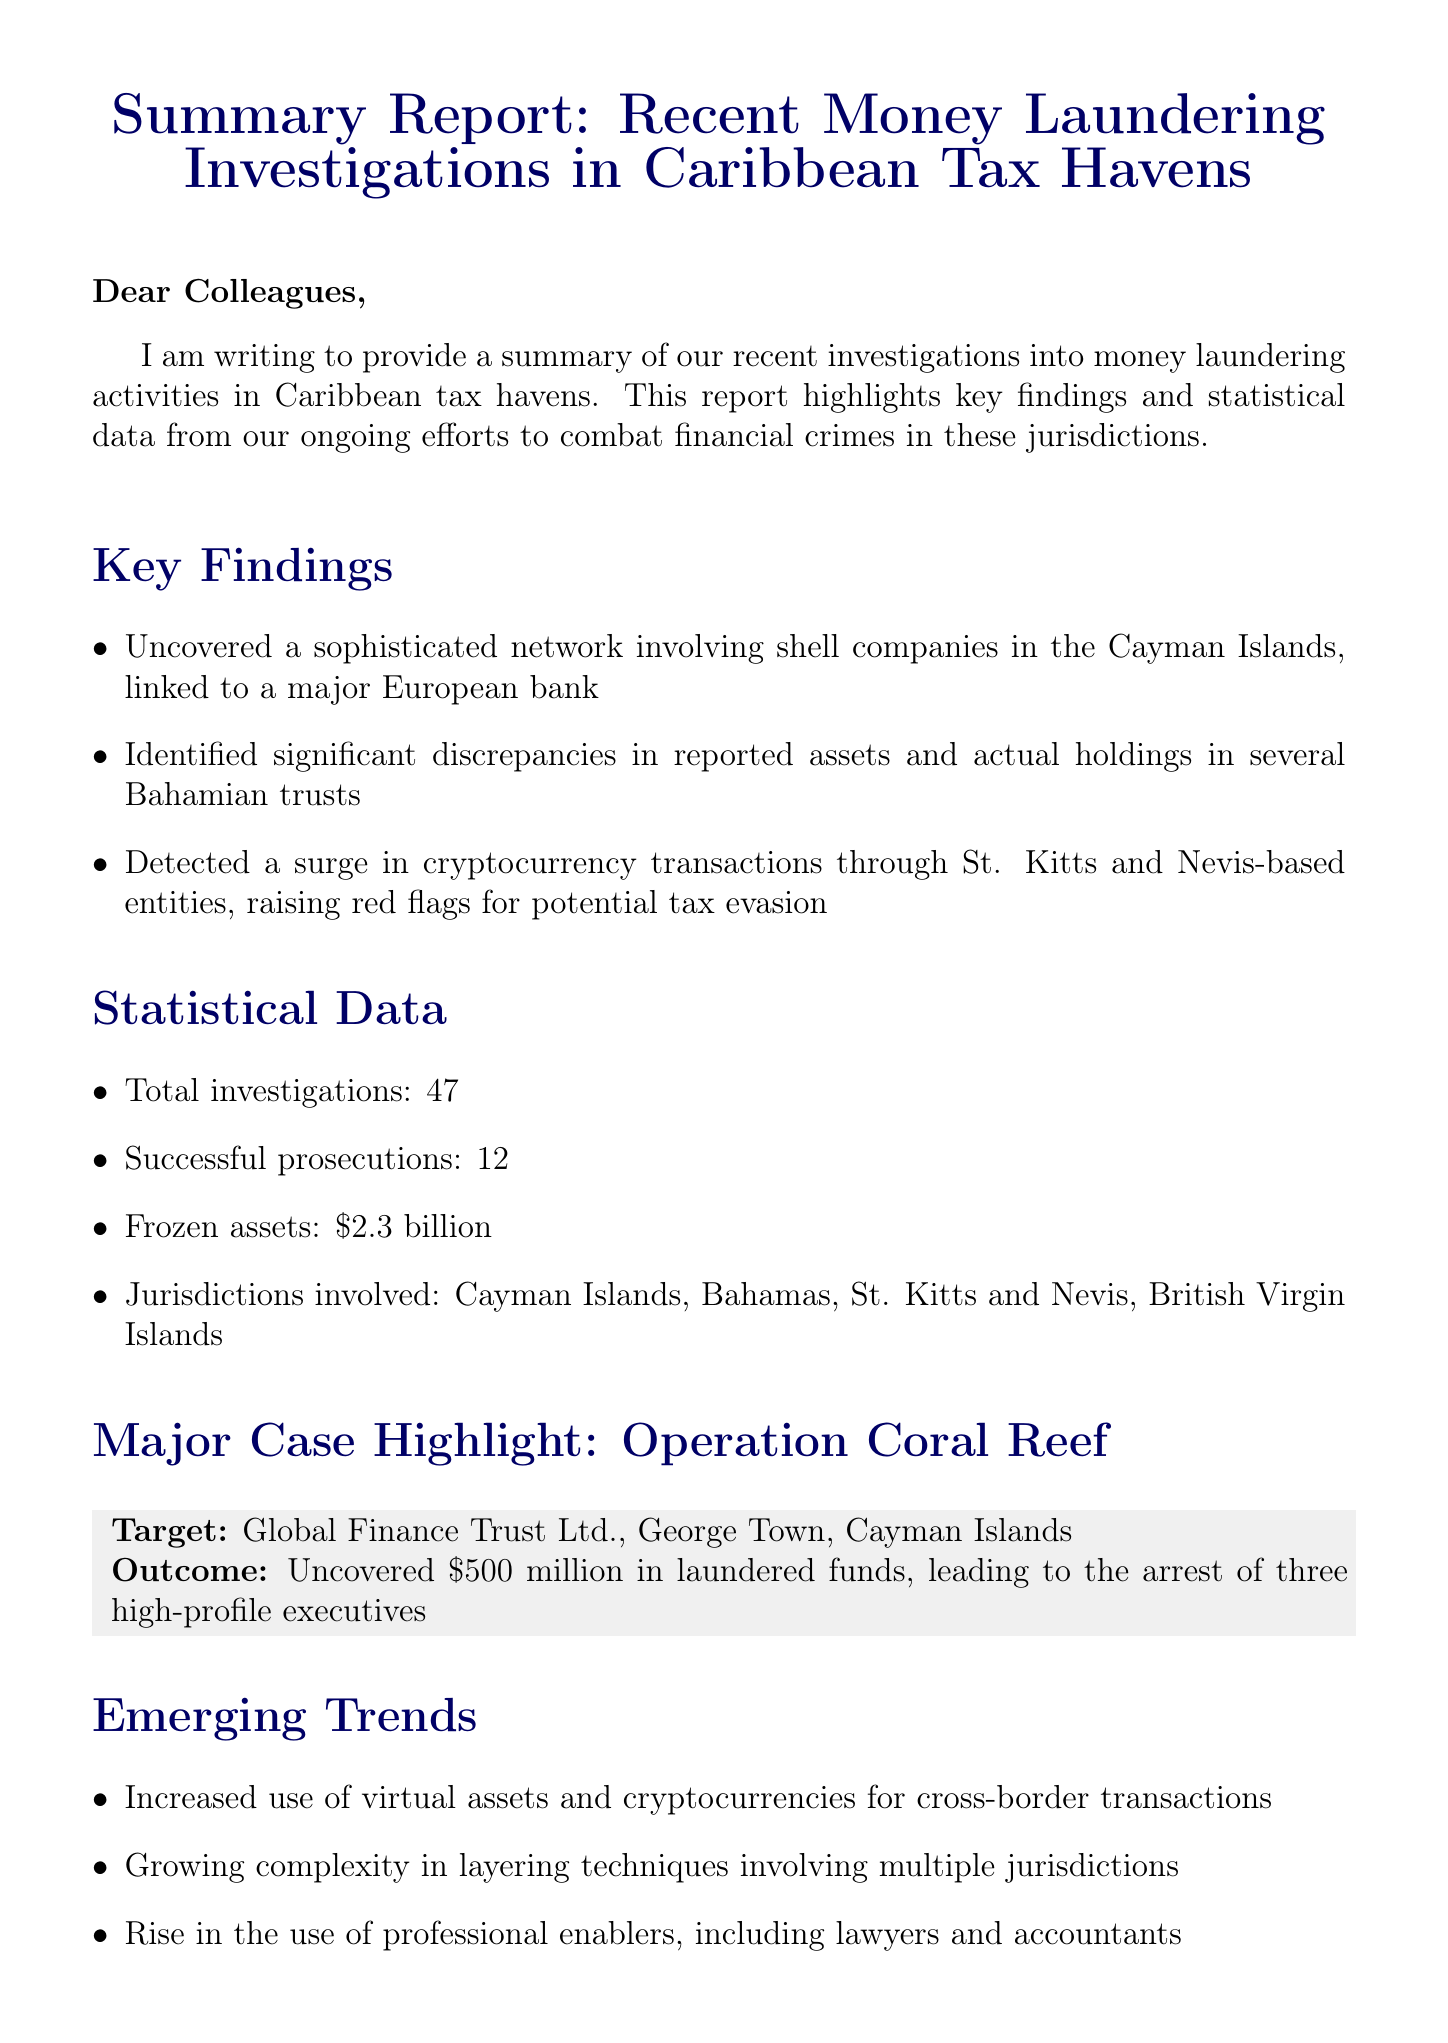What is the total number of investigations? The total number of investigations is included in the statistical data section of the report.
Answer: 47 How many successful prosecutions were reported? The number of successful prosecutions is provided in the statistical data section.
Answer: 12 What amount in frozen assets was noted? The frozen assets figure can be found in the statistical data section of the report.
Answer: $2.3 billion Which major operation targeted Global Finance Trust Ltd.? The name of the major operation that involved Global Finance Trust Ltd. is mentioned in the major case highlight section.
Answer: Operation Coral Reef What trend is emerging regarding virtual assets? The report identifies a specific trend regarding virtual assets in the emerging trends section.
Answer: Increased use What discrepancies were identified in Bahamian trusts? The specific issue found in Bahamian trusts is noted in the key findings section.
Answer: Significant discrepancies in reported assets and actual holdings What jurisdictions were involved in the investigations? The jurisdictions involved are listed in the statistical data section of the report.
Answer: Cayman Islands, Bahamas, St. Kitts and Nevis, British Virgin Islands What is one recommendation made in the report? The recommendations provided in the report include suggestions on addressing the issues identified during investigations.
Answer: Enhance cooperation with local financial intelligence units 